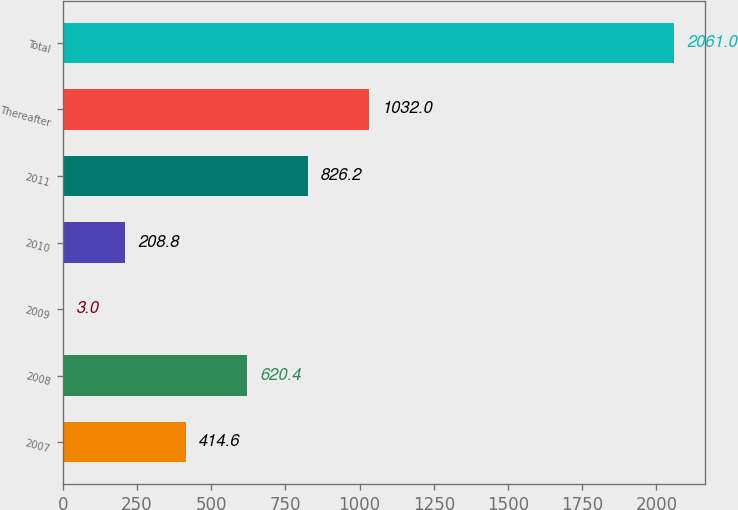<chart> <loc_0><loc_0><loc_500><loc_500><bar_chart><fcel>2007<fcel>2008<fcel>2009<fcel>2010<fcel>2011<fcel>Thereafter<fcel>Total<nl><fcel>414.6<fcel>620.4<fcel>3<fcel>208.8<fcel>826.2<fcel>1032<fcel>2061<nl></chart> 